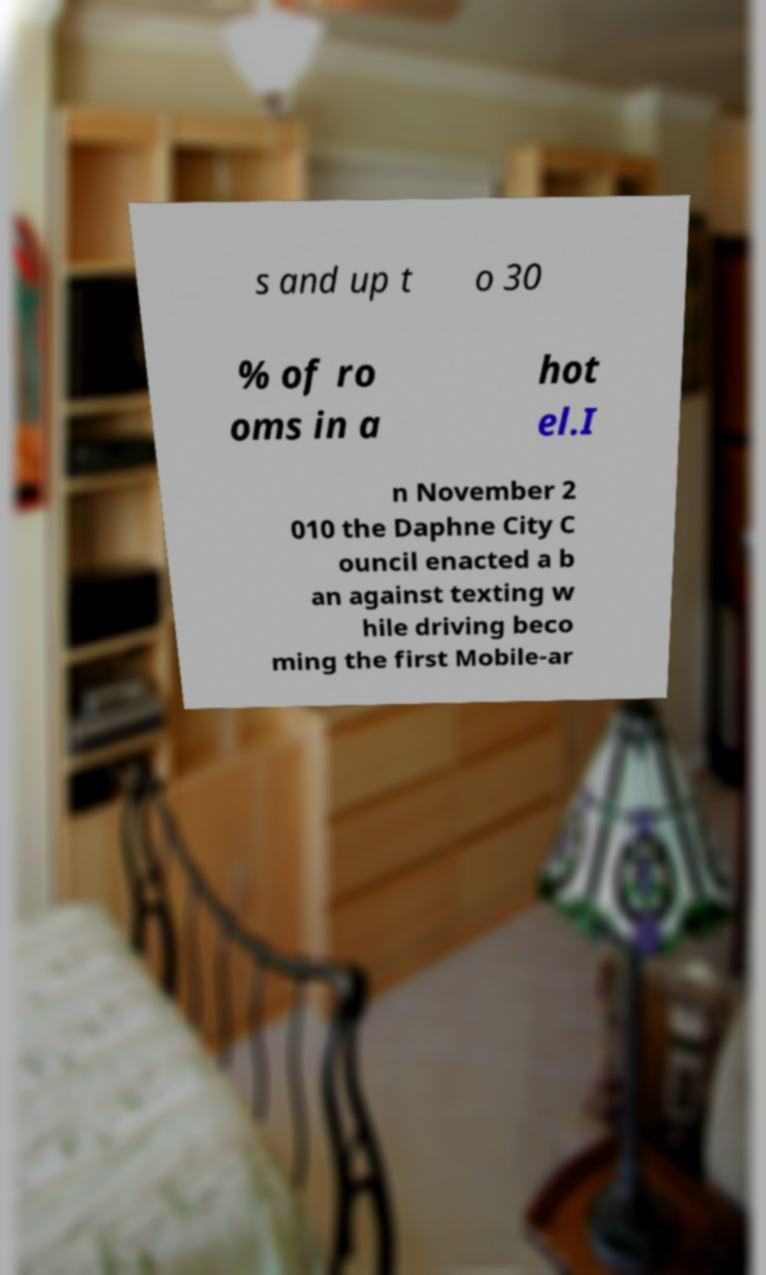Can you read and provide the text displayed in the image?This photo seems to have some interesting text. Can you extract and type it out for me? s and up t o 30 % of ro oms in a hot el.I n November 2 010 the Daphne City C ouncil enacted a b an against texting w hile driving beco ming the first Mobile-ar 